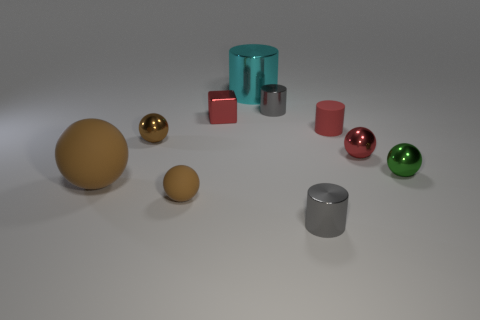The small rubber thing that is the same shape as the big cyan metal object is what color?
Keep it short and to the point. Red. Are there any other things that are the same shape as the large metallic thing?
Provide a short and direct response. Yes. There is a gray metallic thing that is in front of the metal block; what is its shape?
Give a very brief answer. Cylinder. What number of other big things are the same shape as the large cyan metal thing?
Your answer should be very brief. 0. There is a small cylinder behind the matte cylinder; is its color the same as the shiny block in front of the large cyan shiny object?
Make the answer very short. No. What number of objects are either large blue metallic cylinders or small matte things?
Your answer should be very brief. 2. What number of brown things are made of the same material as the cyan thing?
Keep it short and to the point. 1. Is the number of blue matte blocks less than the number of small metal objects?
Your answer should be compact. Yes. Do the red object to the left of the cyan object and the large brown sphere have the same material?
Make the answer very short. No. How many cylinders are tiny red metallic things or blue objects?
Ensure brevity in your answer.  0. 